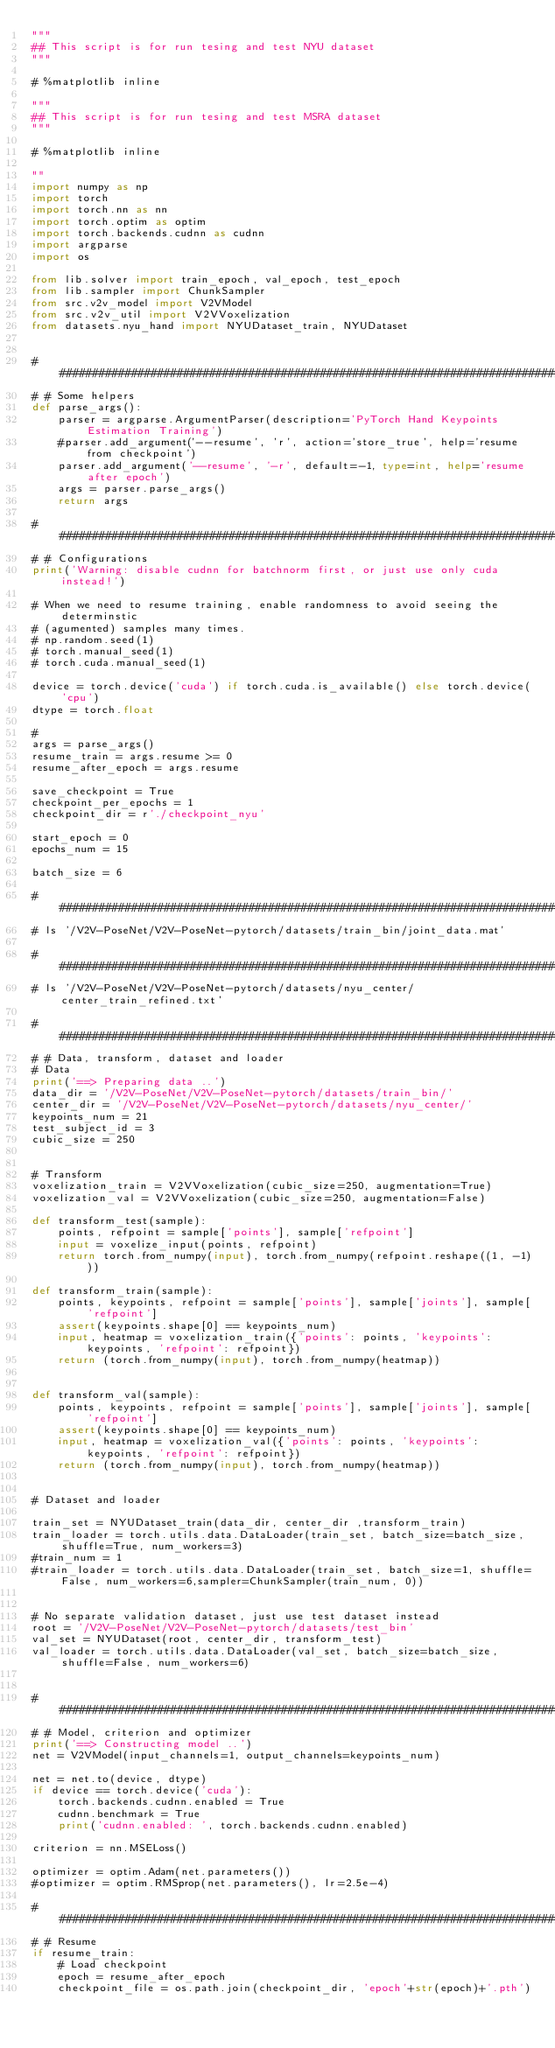Convert code to text. <code><loc_0><loc_0><loc_500><loc_500><_Python_>"""
## This script is for run tesing and test NYU dataset
"""

# %matplotlib inline

"""
## This script is for run tesing and test MSRA dataset
"""

# %matplotlib inline

""
import numpy as np
import torch
import torch.nn as nn
import torch.optim as optim
import torch.backends.cudnn as cudnn
import argparse
import os

from lib.solver import train_epoch, val_epoch, test_epoch
from lib.sampler import ChunkSampler
from src.v2v_model import V2VModel
from src.v2v_util import V2VVoxelization
from datasets.nyu_hand import NYUDataset_train, NYUDataset


#######################################################################################
# # Some helpers
def parse_args():
    parser = argparse.ArgumentParser(description='PyTorch Hand Keypoints Estimation Training')
    #parser.add_argument('--resume', 'r', action='store_true', help='resume from checkpoint')
    parser.add_argument('--resume', '-r', default=-1, type=int, help='resume after epoch')
    args = parser.parse_args()
    return args

#######################################################################################
# # Configurations
print('Warning: disable cudnn for batchnorm first, or just use only cuda instead!')

# When we need to resume training, enable randomness to avoid seeing the determinstic
# (agumented) samples many times.
# np.random.seed(1)
# torch.manual_seed(1)
# torch.cuda.manual_seed(1)

device = torch.device('cuda') if torch.cuda.is_available() else torch.device('cpu')
dtype = torch.float

#
args = parse_args()
resume_train = args.resume >= 0
resume_after_epoch = args.resume

save_checkpoint = True
checkpoint_per_epochs = 1
checkpoint_dir = r'./checkpoint_nyu'

start_epoch = 0
epochs_num = 15

batch_size = 6

###############################################################################
# ls '/V2V-PoseNet/V2V-PoseNet-pytorch/datasets/train_bin/joint_data.mat' 

###############################################################################
# ls '/V2V-PoseNet/V2V-PoseNet-pytorch/datasets/nyu_center/center_train_refined.txt' 

#######################################################################################
# # Data, transform, dataset and loader
# Data
print('==> Preparing data ..')
data_dir = '/V2V-PoseNet/V2V-PoseNet-pytorch/datasets/train_bin/'
center_dir = '/V2V-PoseNet/V2V-PoseNet-pytorch/datasets/nyu_center/'
keypoints_num = 21
test_subject_id = 3
cubic_size = 250


# Transform
voxelization_train = V2VVoxelization(cubic_size=250, augmentation=True)
voxelization_val = V2VVoxelization(cubic_size=250, augmentation=False)

def transform_test(sample):
    points, refpoint = sample['points'], sample['refpoint']
    input = voxelize_input(points, refpoint)
    return torch.from_numpy(input), torch.from_numpy(refpoint.reshape((1, -1)))

def transform_train(sample):
    points, keypoints, refpoint = sample['points'], sample['joints'], sample['refpoint']
    assert(keypoints.shape[0] == keypoints_num)
    input, heatmap = voxelization_train({'points': points, 'keypoints': keypoints, 'refpoint': refpoint})
    return (torch.from_numpy(input), torch.from_numpy(heatmap))


def transform_val(sample):
    points, keypoints, refpoint = sample['points'], sample['joints'], sample['refpoint']
    assert(keypoints.shape[0] == keypoints_num)
    input, heatmap = voxelization_val({'points': points, 'keypoints': keypoints, 'refpoint': refpoint})
    return (torch.from_numpy(input), torch.from_numpy(heatmap))


# Dataset and loader

train_set = NYUDataset_train(data_dir, center_dir ,transform_train)
train_loader = torch.utils.data.DataLoader(train_set, batch_size=batch_size, shuffle=True, num_workers=3)
#train_num = 1
#train_loader = torch.utils.data.DataLoader(train_set, batch_size=1, shuffle=False, num_workers=6,sampler=ChunkSampler(train_num, 0))


# No separate validation dataset, just use test dataset instead
root = '/V2V-PoseNet/V2V-PoseNet-pytorch/datasets/test_bin'
val_set = NYUDataset(root, center_dir, transform_test)
val_loader = torch.utils.data.DataLoader(val_set, batch_size=batch_size, shuffle=False, num_workers=6)


#######################################################################################
# # Model, criterion and optimizer
print('==> Constructing model ..')
net = V2VModel(input_channels=1, output_channels=keypoints_num)

net = net.to(device, dtype)
if device == torch.device('cuda'):
    torch.backends.cudnn.enabled = True
    cudnn.benchmark = True
    print('cudnn.enabled: ', torch.backends.cudnn.enabled)

criterion = nn.MSELoss()

optimizer = optim.Adam(net.parameters())
#optimizer = optim.RMSprop(net.parameters(), lr=2.5e-4)

#######################################################################################
# # Resume
if resume_train:
    # Load checkpoint
    epoch = resume_after_epoch
    checkpoint_file = os.path.join(checkpoint_dir, 'epoch'+str(epoch)+'.pth')
</code> 